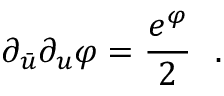<formula> <loc_0><loc_0><loc_500><loc_500>\partial _ { \bar { u } } \partial _ { u } \varphi = { \frac { e ^ { \varphi } } { 2 } } \ \ .</formula> 